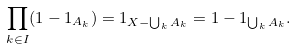Convert formula to latex. <formula><loc_0><loc_0><loc_500><loc_500>\prod _ { k \in I } ( 1 - 1 _ { A _ { k } } ) = 1 _ { X - \bigcup _ { k } A _ { k } } = 1 - 1 _ { \bigcup _ { k } A _ { k } } .</formula> 